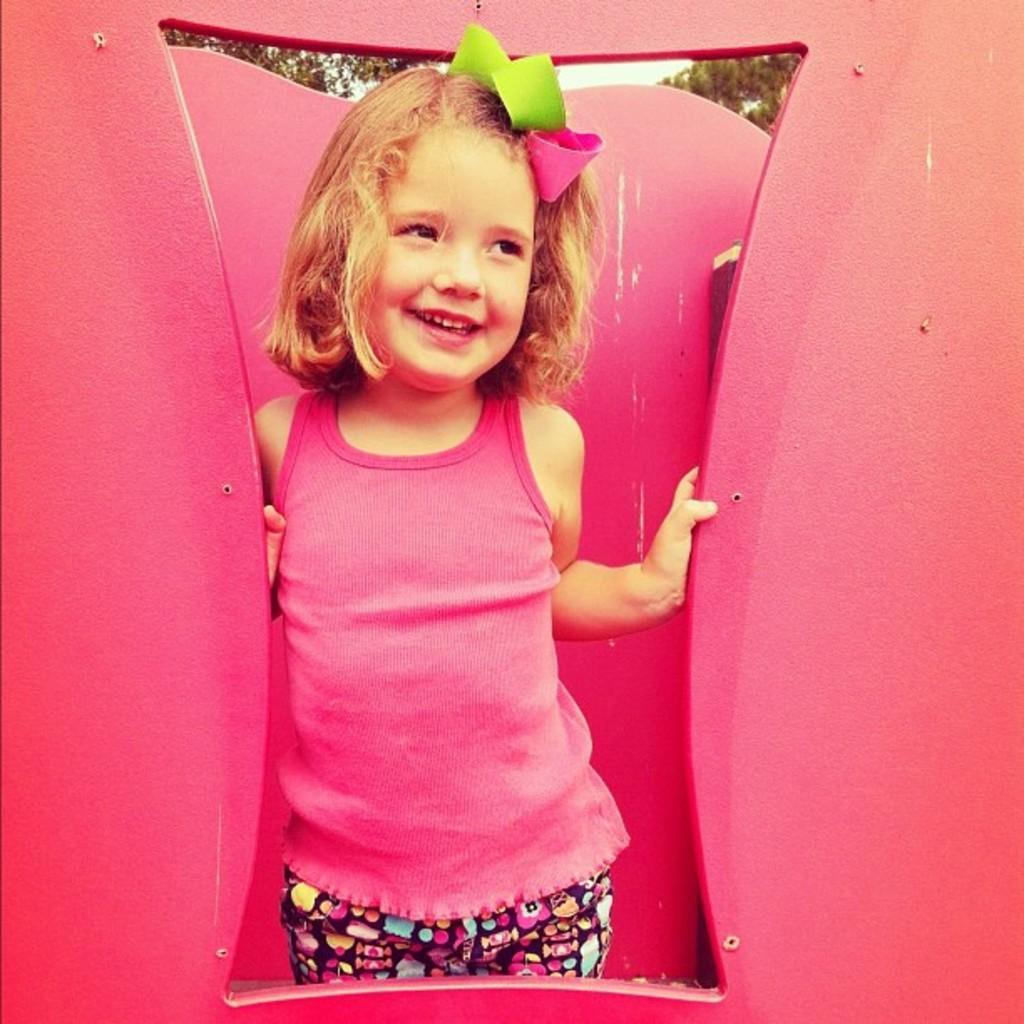How would you summarize this image in a sentence or two? The girl in the pink T-shirt is standing and she is standing. She is smiling. We see the ribbons in green and pink color are tied to her hair. Beside her, we see something in pink color. It looks like a board. There are trees in the background. 